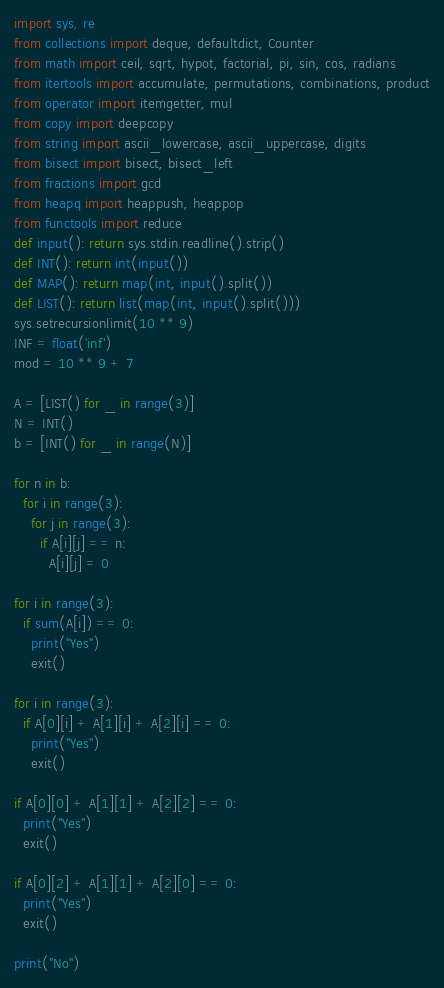<code> <loc_0><loc_0><loc_500><loc_500><_Python_>import sys, re
from collections import deque, defaultdict, Counter
from math import ceil, sqrt, hypot, factorial, pi, sin, cos, radians
from itertools import accumulate, permutations, combinations, product
from operator import itemgetter, mul
from copy import deepcopy
from string import ascii_lowercase, ascii_uppercase, digits
from bisect import bisect, bisect_left
from fractions import gcd
from heapq import heappush, heappop
from functools import reduce
def input(): return sys.stdin.readline().strip()
def INT(): return int(input())
def MAP(): return map(int, input().split())
def LIST(): return list(map(int, input().split()))
sys.setrecursionlimit(10 ** 9)
INF = float('inf')
mod = 10 ** 9 + 7

A = [LIST() for _ in range(3)]
N = INT()
b = [INT() for _ in range(N)]

for n in b:
  for i in range(3):
    for j in range(3):
      if A[i][j] == n:
        A[i][j] = 0
        
for i in range(3):
  if sum(A[i]) == 0:
    print("Yes")
    exit()
    
for i in range(3):
  if A[0][i] + A[1][i] + A[2][i] == 0:
    print("Yes")
    exit()
    
if A[0][0] + A[1][1] + A[2][2] == 0:
  print("Yes")
  exit()
  
if A[0][2] + A[1][1] + A[2][0] == 0:
  print("Yes")
  exit()
  
print("No")</code> 